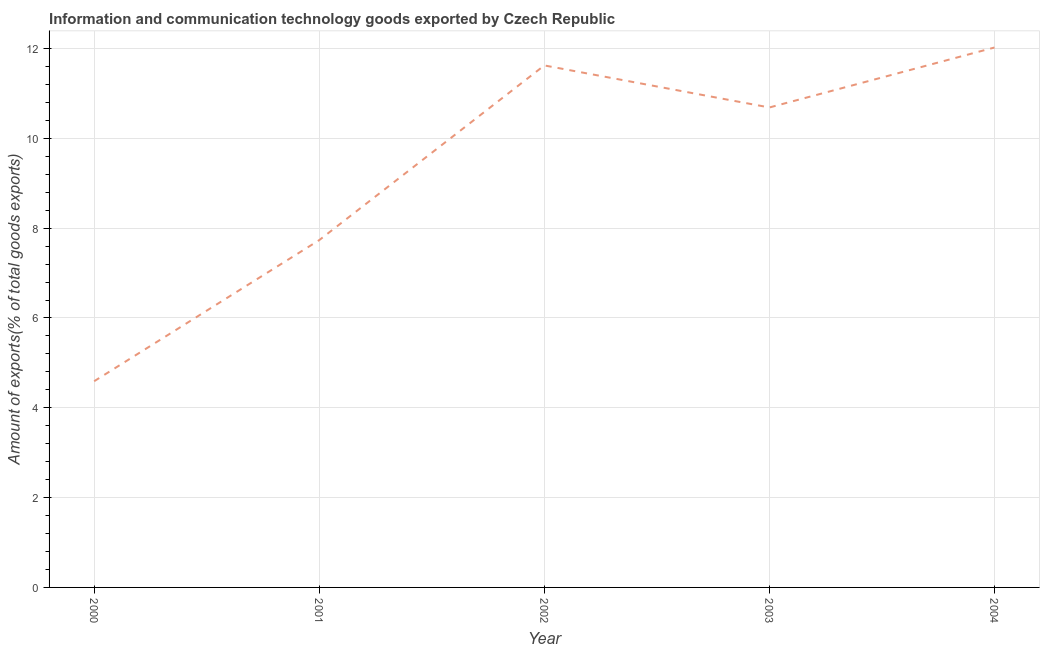What is the amount of ict goods exports in 2001?
Offer a terse response. 7.73. Across all years, what is the maximum amount of ict goods exports?
Your answer should be compact. 12.02. Across all years, what is the minimum amount of ict goods exports?
Keep it short and to the point. 4.59. What is the sum of the amount of ict goods exports?
Provide a short and direct response. 46.66. What is the difference between the amount of ict goods exports in 2000 and 2003?
Make the answer very short. -6.1. What is the average amount of ict goods exports per year?
Offer a terse response. 9.33. What is the median amount of ict goods exports?
Your response must be concise. 10.69. In how many years, is the amount of ict goods exports greater than 5.6 %?
Your answer should be very brief. 4. What is the ratio of the amount of ict goods exports in 2003 to that in 2004?
Offer a terse response. 0.89. Is the amount of ict goods exports in 2001 less than that in 2003?
Provide a succinct answer. Yes. Is the difference between the amount of ict goods exports in 2000 and 2004 greater than the difference between any two years?
Your response must be concise. Yes. What is the difference between the highest and the second highest amount of ict goods exports?
Offer a very short reply. 0.4. Is the sum of the amount of ict goods exports in 2002 and 2003 greater than the maximum amount of ict goods exports across all years?
Provide a short and direct response. Yes. What is the difference between the highest and the lowest amount of ict goods exports?
Ensure brevity in your answer.  7.43. How many lines are there?
Make the answer very short. 1. How many years are there in the graph?
Offer a very short reply. 5. Are the values on the major ticks of Y-axis written in scientific E-notation?
Your answer should be compact. No. Does the graph contain any zero values?
Provide a short and direct response. No. What is the title of the graph?
Offer a terse response. Information and communication technology goods exported by Czech Republic. What is the label or title of the Y-axis?
Your answer should be compact. Amount of exports(% of total goods exports). What is the Amount of exports(% of total goods exports) in 2000?
Ensure brevity in your answer.  4.59. What is the Amount of exports(% of total goods exports) in 2001?
Offer a very short reply. 7.73. What is the Amount of exports(% of total goods exports) in 2002?
Offer a terse response. 11.62. What is the Amount of exports(% of total goods exports) in 2003?
Offer a very short reply. 10.69. What is the Amount of exports(% of total goods exports) in 2004?
Your response must be concise. 12.02. What is the difference between the Amount of exports(% of total goods exports) in 2000 and 2001?
Make the answer very short. -3.14. What is the difference between the Amount of exports(% of total goods exports) in 2000 and 2002?
Offer a very short reply. -7.03. What is the difference between the Amount of exports(% of total goods exports) in 2000 and 2003?
Keep it short and to the point. -6.1. What is the difference between the Amount of exports(% of total goods exports) in 2000 and 2004?
Provide a short and direct response. -7.43. What is the difference between the Amount of exports(% of total goods exports) in 2001 and 2002?
Your answer should be compact. -3.89. What is the difference between the Amount of exports(% of total goods exports) in 2001 and 2003?
Your answer should be very brief. -2.95. What is the difference between the Amount of exports(% of total goods exports) in 2001 and 2004?
Offer a terse response. -4.29. What is the difference between the Amount of exports(% of total goods exports) in 2002 and 2003?
Your answer should be compact. 0.94. What is the difference between the Amount of exports(% of total goods exports) in 2002 and 2004?
Your answer should be very brief. -0.4. What is the difference between the Amount of exports(% of total goods exports) in 2003 and 2004?
Ensure brevity in your answer.  -1.34. What is the ratio of the Amount of exports(% of total goods exports) in 2000 to that in 2001?
Your response must be concise. 0.59. What is the ratio of the Amount of exports(% of total goods exports) in 2000 to that in 2002?
Provide a short and direct response. 0.4. What is the ratio of the Amount of exports(% of total goods exports) in 2000 to that in 2003?
Your response must be concise. 0.43. What is the ratio of the Amount of exports(% of total goods exports) in 2000 to that in 2004?
Keep it short and to the point. 0.38. What is the ratio of the Amount of exports(% of total goods exports) in 2001 to that in 2002?
Your answer should be compact. 0.67. What is the ratio of the Amount of exports(% of total goods exports) in 2001 to that in 2003?
Give a very brief answer. 0.72. What is the ratio of the Amount of exports(% of total goods exports) in 2001 to that in 2004?
Make the answer very short. 0.64. What is the ratio of the Amount of exports(% of total goods exports) in 2002 to that in 2003?
Ensure brevity in your answer.  1.09. What is the ratio of the Amount of exports(% of total goods exports) in 2002 to that in 2004?
Ensure brevity in your answer.  0.97. What is the ratio of the Amount of exports(% of total goods exports) in 2003 to that in 2004?
Give a very brief answer. 0.89. 